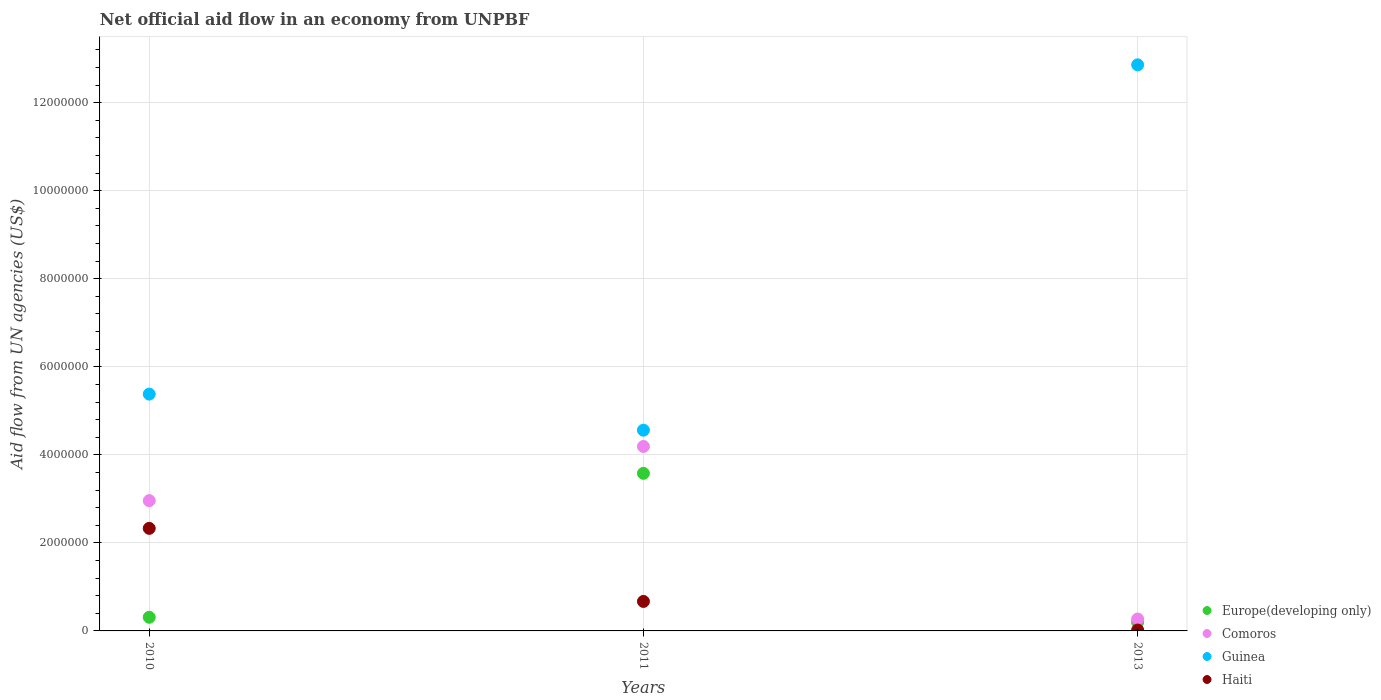Is the number of dotlines equal to the number of legend labels?
Provide a short and direct response. Yes. What is the net official aid flow in Guinea in 2011?
Make the answer very short. 4.56e+06. Across all years, what is the maximum net official aid flow in Europe(developing only)?
Provide a succinct answer. 3.58e+06. In which year was the net official aid flow in Haiti maximum?
Ensure brevity in your answer.  2010. What is the total net official aid flow in Comoros in the graph?
Offer a terse response. 7.42e+06. What is the difference between the net official aid flow in Guinea in 2010 and that in 2011?
Give a very brief answer. 8.20e+05. What is the difference between the net official aid flow in Europe(developing only) in 2011 and the net official aid flow in Guinea in 2010?
Offer a terse response. -1.80e+06. What is the average net official aid flow in Haiti per year?
Make the answer very short. 1.01e+06. In the year 2010, what is the difference between the net official aid flow in Comoros and net official aid flow in Guinea?
Offer a terse response. -2.42e+06. In how many years, is the net official aid flow in Europe(developing only) greater than 10000000 US$?
Your answer should be compact. 0. What is the difference between the highest and the second highest net official aid flow in Haiti?
Your answer should be very brief. 1.66e+06. What is the difference between the highest and the lowest net official aid flow in Haiti?
Ensure brevity in your answer.  2.31e+06. Is the sum of the net official aid flow in Europe(developing only) in 2011 and 2013 greater than the maximum net official aid flow in Haiti across all years?
Provide a short and direct response. Yes. Is it the case that in every year, the sum of the net official aid flow in Haiti and net official aid flow in Europe(developing only)  is greater than the sum of net official aid flow in Comoros and net official aid flow in Guinea?
Offer a very short reply. No. Is it the case that in every year, the sum of the net official aid flow in Guinea and net official aid flow in Comoros  is greater than the net official aid flow in Europe(developing only)?
Your answer should be compact. Yes. Is the net official aid flow in Guinea strictly greater than the net official aid flow in Europe(developing only) over the years?
Give a very brief answer. Yes. Are the values on the major ticks of Y-axis written in scientific E-notation?
Keep it short and to the point. No. Does the graph contain any zero values?
Offer a very short reply. No. Does the graph contain grids?
Your answer should be compact. Yes. How are the legend labels stacked?
Your answer should be very brief. Vertical. What is the title of the graph?
Ensure brevity in your answer.  Net official aid flow in an economy from UNPBF. Does "West Bank and Gaza" appear as one of the legend labels in the graph?
Your answer should be compact. No. What is the label or title of the X-axis?
Ensure brevity in your answer.  Years. What is the label or title of the Y-axis?
Your answer should be very brief. Aid flow from UN agencies (US$). What is the Aid flow from UN agencies (US$) in Comoros in 2010?
Give a very brief answer. 2.96e+06. What is the Aid flow from UN agencies (US$) of Guinea in 2010?
Ensure brevity in your answer.  5.38e+06. What is the Aid flow from UN agencies (US$) in Haiti in 2010?
Your answer should be very brief. 2.33e+06. What is the Aid flow from UN agencies (US$) of Europe(developing only) in 2011?
Provide a succinct answer. 3.58e+06. What is the Aid flow from UN agencies (US$) of Comoros in 2011?
Your answer should be compact. 4.19e+06. What is the Aid flow from UN agencies (US$) of Guinea in 2011?
Provide a succinct answer. 4.56e+06. What is the Aid flow from UN agencies (US$) in Haiti in 2011?
Your response must be concise. 6.70e+05. What is the Aid flow from UN agencies (US$) in Europe(developing only) in 2013?
Give a very brief answer. 2.00e+05. What is the Aid flow from UN agencies (US$) in Guinea in 2013?
Your response must be concise. 1.29e+07. What is the Aid flow from UN agencies (US$) in Haiti in 2013?
Make the answer very short. 2.00e+04. Across all years, what is the maximum Aid flow from UN agencies (US$) of Europe(developing only)?
Provide a succinct answer. 3.58e+06. Across all years, what is the maximum Aid flow from UN agencies (US$) of Comoros?
Make the answer very short. 4.19e+06. Across all years, what is the maximum Aid flow from UN agencies (US$) in Guinea?
Make the answer very short. 1.29e+07. Across all years, what is the maximum Aid flow from UN agencies (US$) in Haiti?
Make the answer very short. 2.33e+06. Across all years, what is the minimum Aid flow from UN agencies (US$) in Europe(developing only)?
Your response must be concise. 2.00e+05. Across all years, what is the minimum Aid flow from UN agencies (US$) of Comoros?
Your answer should be compact. 2.70e+05. Across all years, what is the minimum Aid flow from UN agencies (US$) of Guinea?
Give a very brief answer. 4.56e+06. Across all years, what is the minimum Aid flow from UN agencies (US$) in Haiti?
Offer a very short reply. 2.00e+04. What is the total Aid flow from UN agencies (US$) in Europe(developing only) in the graph?
Make the answer very short. 4.09e+06. What is the total Aid flow from UN agencies (US$) in Comoros in the graph?
Give a very brief answer. 7.42e+06. What is the total Aid flow from UN agencies (US$) of Guinea in the graph?
Ensure brevity in your answer.  2.28e+07. What is the total Aid flow from UN agencies (US$) of Haiti in the graph?
Provide a short and direct response. 3.02e+06. What is the difference between the Aid flow from UN agencies (US$) in Europe(developing only) in 2010 and that in 2011?
Your answer should be compact. -3.27e+06. What is the difference between the Aid flow from UN agencies (US$) in Comoros in 2010 and that in 2011?
Your answer should be compact. -1.23e+06. What is the difference between the Aid flow from UN agencies (US$) of Guinea in 2010 and that in 2011?
Your answer should be compact. 8.20e+05. What is the difference between the Aid flow from UN agencies (US$) in Haiti in 2010 and that in 2011?
Your response must be concise. 1.66e+06. What is the difference between the Aid flow from UN agencies (US$) of Europe(developing only) in 2010 and that in 2013?
Your answer should be compact. 1.10e+05. What is the difference between the Aid flow from UN agencies (US$) in Comoros in 2010 and that in 2013?
Your answer should be compact. 2.69e+06. What is the difference between the Aid flow from UN agencies (US$) in Guinea in 2010 and that in 2013?
Provide a short and direct response. -7.48e+06. What is the difference between the Aid flow from UN agencies (US$) of Haiti in 2010 and that in 2013?
Offer a terse response. 2.31e+06. What is the difference between the Aid flow from UN agencies (US$) in Europe(developing only) in 2011 and that in 2013?
Ensure brevity in your answer.  3.38e+06. What is the difference between the Aid flow from UN agencies (US$) in Comoros in 2011 and that in 2013?
Ensure brevity in your answer.  3.92e+06. What is the difference between the Aid flow from UN agencies (US$) in Guinea in 2011 and that in 2013?
Make the answer very short. -8.30e+06. What is the difference between the Aid flow from UN agencies (US$) in Haiti in 2011 and that in 2013?
Make the answer very short. 6.50e+05. What is the difference between the Aid flow from UN agencies (US$) of Europe(developing only) in 2010 and the Aid flow from UN agencies (US$) of Comoros in 2011?
Keep it short and to the point. -3.88e+06. What is the difference between the Aid flow from UN agencies (US$) in Europe(developing only) in 2010 and the Aid flow from UN agencies (US$) in Guinea in 2011?
Give a very brief answer. -4.25e+06. What is the difference between the Aid flow from UN agencies (US$) of Europe(developing only) in 2010 and the Aid flow from UN agencies (US$) of Haiti in 2011?
Your answer should be very brief. -3.60e+05. What is the difference between the Aid flow from UN agencies (US$) of Comoros in 2010 and the Aid flow from UN agencies (US$) of Guinea in 2011?
Make the answer very short. -1.60e+06. What is the difference between the Aid flow from UN agencies (US$) of Comoros in 2010 and the Aid flow from UN agencies (US$) of Haiti in 2011?
Ensure brevity in your answer.  2.29e+06. What is the difference between the Aid flow from UN agencies (US$) in Guinea in 2010 and the Aid flow from UN agencies (US$) in Haiti in 2011?
Offer a terse response. 4.71e+06. What is the difference between the Aid flow from UN agencies (US$) of Europe(developing only) in 2010 and the Aid flow from UN agencies (US$) of Comoros in 2013?
Your response must be concise. 4.00e+04. What is the difference between the Aid flow from UN agencies (US$) in Europe(developing only) in 2010 and the Aid flow from UN agencies (US$) in Guinea in 2013?
Offer a very short reply. -1.26e+07. What is the difference between the Aid flow from UN agencies (US$) of Europe(developing only) in 2010 and the Aid flow from UN agencies (US$) of Haiti in 2013?
Your answer should be compact. 2.90e+05. What is the difference between the Aid flow from UN agencies (US$) of Comoros in 2010 and the Aid flow from UN agencies (US$) of Guinea in 2013?
Your answer should be compact. -9.90e+06. What is the difference between the Aid flow from UN agencies (US$) of Comoros in 2010 and the Aid flow from UN agencies (US$) of Haiti in 2013?
Provide a succinct answer. 2.94e+06. What is the difference between the Aid flow from UN agencies (US$) of Guinea in 2010 and the Aid flow from UN agencies (US$) of Haiti in 2013?
Keep it short and to the point. 5.36e+06. What is the difference between the Aid flow from UN agencies (US$) in Europe(developing only) in 2011 and the Aid flow from UN agencies (US$) in Comoros in 2013?
Ensure brevity in your answer.  3.31e+06. What is the difference between the Aid flow from UN agencies (US$) in Europe(developing only) in 2011 and the Aid flow from UN agencies (US$) in Guinea in 2013?
Keep it short and to the point. -9.28e+06. What is the difference between the Aid flow from UN agencies (US$) in Europe(developing only) in 2011 and the Aid flow from UN agencies (US$) in Haiti in 2013?
Offer a terse response. 3.56e+06. What is the difference between the Aid flow from UN agencies (US$) in Comoros in 2011 and the Aid flow from UN agencies (US$) in Guinea in 2013?
Ensure brevity in your answer.  -8.67e+06. What is the difference between the Aid flow from UN agencies (US$) of Comoros in 2011 and the Aid flow from UN agencies (US$) of Haiti in 2013?
Provide a succinct answer. 4.17e+06. What is the difference between the Aid flow from UN agencies (US$) of Guinea in 2011 and the Aid flow from UN agencies (US$) of Haiti in 2013?
Your answer should be very brief. 4.54e+06. What is the average Aid flow from UN agencies (US$) of Europe(developing only) per year?
Give a very brief answer. 1.36e+06. What is the average Aid flow from UN agencies (US$) of Comoros per year?
Offer a very short reply. 2.47e+06. What is the average Aid flow from UN agencies (US$) of Guinea per year?
Provide a succinct answer. 7.60e+06. What is the average Aid flow from UN agencies (US$) in Haiti per year?
Ensure brevity in your answer.  1.01e+06. In the year 2010, what is the difference between the Aid flow from UN agencies (US$) of Europe(developing only) and Aid flow from UN agencies (US$) of Comoros?
Ensure brevity in your answer.  -2.65e+06. In the year 2010, what is the difference between the Aid flow from UN agencies (US$) of Europe(developing only) and Aid flow from UN agencies (US$) of Guinea?
Provide a short and direct response. -5.07e+06. In the year 2010, what is the difference between the Aid flow from UN agencies (US$) in Europe(developing only) and Aid flow from UN agencies (US$) in Haiti?
Your answer should be compact. -2.02e+06. In the year 2010, what is the difference between the Aid flow from UN agencies (US$) in Comoros and Aid flow from UN agencies (US$) in Guinea?
Keep it short and to the point. -2.42e+06. In the year 2010, what is the difference between the Aid flow from UN agencies (US$) in Comoros and Aid flow from UN agencies (US$) in Haiti?
Give a very brief answer. 6.30e+05. In the year 2010, what is the difference between the Aid flow from UN agencies (US$) of Guinea and Aid flow from UN agencies (US$) of Haiti?
Offer a terse response. 3.05e+06. In the year 2011, what is the difference between the Aid flow from UN agencies (US$) in Europe(developing only) and Aid flow from UN agencies (US$) in Comoros?
Keep it short and to the point. -6.10e+05. In the year 2011, what is the difference between the Aid flow from UN agencies (US$) in Europe(developing only) and Aid flow from UN agencies (US$) in Guinea?
Keep it short and to the point. -9.80e+05. In the year 2011, what is the difference between the Aid flow from UN agencies (US$) in Europe(developing only) and Aid flow from UN agencies (US$) in Haiti?
Offer a very short reply. 2.91e+06. In the year 2011, what is the difference between the Aid flow from UN agencies (US$) of Comoros and Aid flow from UN agencies (US$) of Guinea?
Provide a succinct answer. -3.70e+05. In the year 2011, what is the difference between the Aid flow from UN agencies (US$) in Comoros and Aid flow from UN agencies (US$) in Haiti?
Provide a succinct answer. 3.52e+06. In the year 2011, what is the difference between the Aid flow from UN agencies (US$) in Guinea and Aid flow from UN agencies (US$) in Haiti?
Your answer should be compact. 3.89e+06. In the year 2013, what is the difference between the Aid flow from UN agencies (US$) of Europe(developing only) and Aid flow from UN agencies (US$) of Guinea?
Your response must be concise. -1.27e+07. In the year 2013, what is the difference between the Aid flow from UN agencies (US$) in Comoros and Aid flow from UN agencies (US$) in Guinea?
Give a very brief answer. -1.26e+07. In the year 2013, what is the difference between the Aid flow from UN agencies (US$) of Guinea and Aid flow from UN agencies (US$) of Haiti?
Keep it short and to the point. 1.28e+07. What is the ratio of the Aid flow from UN agencies (US$) in Europe(developing only) in 2010 to that in 2011?
Ensure brevity in your answer.  0.09. What is the ratio of the Aid flow from UN agencies (US$) of Comoros in 2010 to that in 2011?
Offer a very short reply. 0.71. What is the ratio of the Aid flow from UN agencies (US$) of Guinea in 2010 to that in 2011?
Keep it short and to the point. 1.18. What is the ratio of the Aid flow from UN agencies (US$) of Haiti in 2010 to that in 2011?
Provide a succinct answer. 3.48. What is the ratio of the Aid flow from UN agencies (US$) in Europe(developing only) in 2010 to that in 2013?
Make the answer very short. 1.55. What is the ratio of the Aid flow from UN agencies (US$) of Comoros in 2010 to that in 2013?
Keep it short and to the point. 10.96. What is the ratio of the Aid flow from UN agencies (US$) of Guinea in 2010 to that in 2013?
Provide a short and direct response. 0.42. What is the ratio of the Aid flow from UN agencies (US$) in Haiti in 2010 to that in 2013?
Your answer should be very brief. 116.5. What is the ratio of the Aid flow from UN agencies (US$) in Europe(developing only) in 2011 to that in 2013?
Make the answer very short. 17.9. What is the ratio of the Aid flow from UN agencies (US$) in Comoros in 2011 to that in 2013?
Your answer should be compact. 15.52. What is the ratio of the Aid flow from UN agencies (US$) of Guinea in 2011 to that in 2013?
Offer a very short reply. 0.35. What is the ratio of the Aid flow from UN agencies (US$) in Haiti in 2011 to that in 2013?
Give a very brief answer. 33.5. What is the difference between the highest and the second highest Aid flow from UN agencies (US$) of Europe(developing only)?
Make the answer very short. 3.27e+06. What is the difference between the highest and the second highest Aid flow from UN agencies (US$) of Comoros?
Offer a very short reply. 1.23e+06. What is the difference between the highest and the second highest Aid flow from UN agencies (US$) in Guinea?
Keep it short and to the point. 7.48e+06. What is the difference between the highest and the second highest Aid flow from UN agencies (US$) of Haiti?
Make the answer very short. 1.66e+06. What is the difference between the highest and the lowest Aid flow from UN agencies (US$) of Europe(developing only)?
Keep it short and to the point. 3.38e+06. What is the difference between the highest and the lowest Aid flow from UN agencies (US$) of Comoros?
Your response must be concise. 3.92e+06. What is the difference between the highest and the lowest Aid flow from UN agencies (US$) in Guinea?
Make the answer very short. 8.30e+06. What is the difference between the highest and the lowest Aid flow from UN agencies (US$) of Haiti?
Keep it short and to the point. 2.31e+06. 